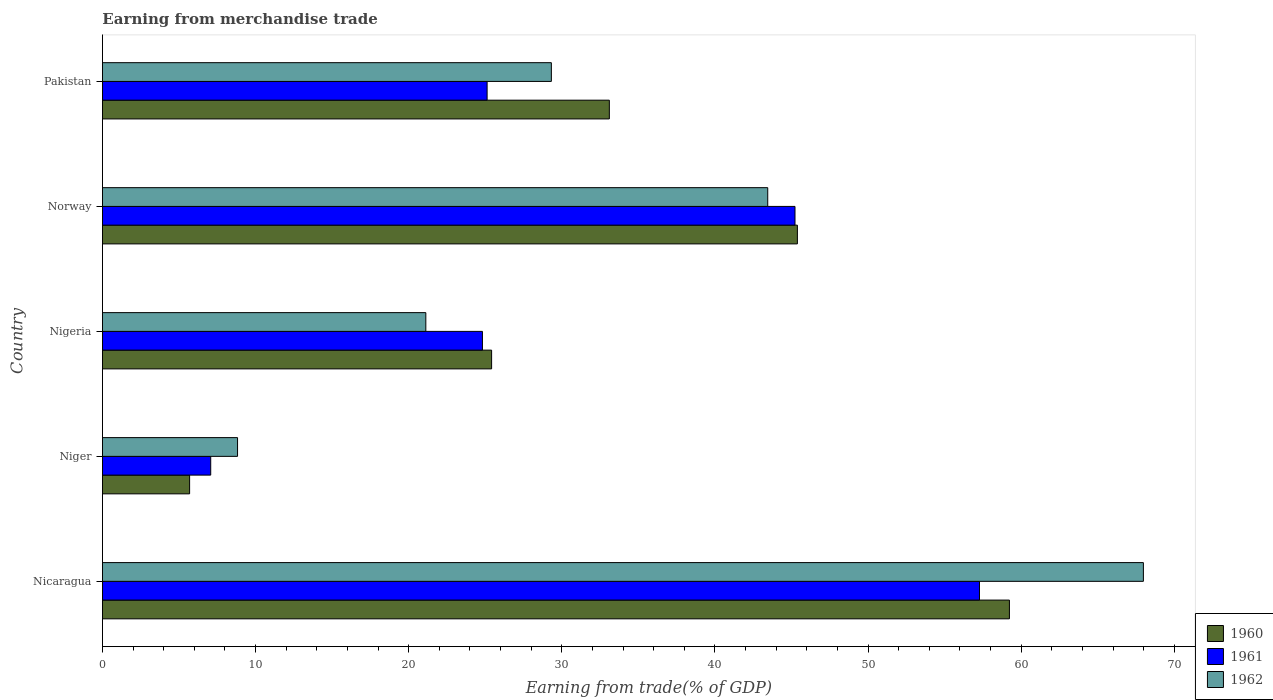How many different coloured bars are there?
Keep it short and to the point. 3. Are the number of bars per tick equal to the number of legend labels?
Your answer should be compact. Yes. How many bars are there on the 2nd tick from the top?
Offer a terse response. 3. How many bars are there on the 2nd tick from the bottom?
Offer a terse response. 3. What is the label of the 2nd group of bars from the top?
Provide a short and direct response. Norway. In how many cases, is the number of bars for a given country not equal to the number of legend labels?
Your response must be concise. 0. What is the earnings from trade in 1960 in Niger?
Offer a terse response. 5.69. Across all countries, what is the maximum earnings from trade in 1962?
Provide a succinct answer. 67.98. Across all countries, what is the minimum earnings from trade in 1961?
Offer a terse response. 7.07. In which country was the earnings from trade in 1960 maximum?
Provide a short and direct response. Nicaragua. In which country was the earnings from trade in 1961 minimum?
Your answer should be very brief. Niger. What is the total earnings from trade in 1962 in the graph?
Your response must be concise. 170.67. What is the difference between the earnings from trade in 1961 in Nigeria and that in Pakistan?
Make the answer very short. -0.31. What is the difference between the earnings from trade in 1962 in Norway and the earnings from trade in 1961 in Nigeria?
Your answer should be compact. 18.63. What is the average earnings from trade in 1960 per country?
Provide a short and direct response. 33.76. What is the difference between the earnings from trade in 1961 and earnings from trade in 1962 in Norway?
Your answer should be very brief. 1.78. What is the ratio of the earnings from trade in 1960 in Niger to that in Nigeria?
Give a very brief answer. 0.22. Is the earnings from trade in 1961 in Nigeria less than that in Pakistan?
Your answer should be compact. Yes. Is the difference between the earnings from trade in 1961 in Niger and Nigeria greater than the difference between the earnings from trade in 1962 in Niger and Nigeria?
Keep it short and to the point. No. What is the difference between the highest and the second highest earnings from trade in 1961?
Your answer should be compact. 12.05. What is the difference between the highest and the lowest earnings from trade in 1960?
Offer a terse response. 53.54. In how many countries, is the earnings from trade in 1960 greater than the average earnings from trade in 1960 taken over all countries?
Provide a short and direct response. 2. Is the sum of the earnings from trade in 1960 in Nicaragua and Niger greater than the maximum earnings from trade in 1962 across all countries?
Keep it short and to the point. No. What does the 2nd bar from the top in Niger represents?
Make the answer very short. 1961. Is it the case that in every country, the sum of the earnings from trade in 1961 and earnings from trade in 1960 is greater than the earnings from trade in 1962?
Your answer should be very brief. Yes. How many bars are there?
Offer a terse response. 15. Are all the bars in the graph horizontal?
Ensure brevity in your answer.  Yes. How many countries are there in the graph?
Your response must be concise. 5. Are the values on the major ticks of X-axis written in scientific E-notation?
Offer a very short reply. No. How many legend labels are there?
Ensure brevity in your answer.  3. What is the title of the graph?
Your response must be concise. Earning from merchandise trade. Does "1996" appear as one of the legend labels in the graph?
Your response must be concise. No. What is the label or title of the X-axis?
Offer a very short reply. Earning from trade(% of GDP). What is the Earning from trade(% of GDP) of 1960 in Nicaragua?
Make the answer very short. 59.23. What is the Earning from trade(% of GDP) of 1961 in Nicaragua?
Ensure brevity in your answer.  57.27. What is the Earning from trade(% of GDP) in 1962 in Nicaragua?
Your response must be concise. 67.98. What is the Earning from trade(% of GDP) in 1960 in Niger?
Provide a short and direct response. 5.69. What is the Earning from trade(% of GDP) of 1961 in Niger?
Offer a terse response. 7.07. What is the Earning from trade(% of GDP) of 1962 in Niger?
Ensure brevity in your answer.  8.82. What is the Earning from trade(% of GDP) of 1960 in Nigeria?
Offer a terse response. 25.41. What is the Earning from trade(% of GDP) of 1961 in Nigeria?
Offer a very short reply. 24.81. What is the Earning from trade(% of GDP) of 1962 in Nigeria?
Your answer should be very brief. 21.12. What is the Earning from trade(% of GDP) of 1960 in Norway?
Your answer should be very brief. 45.38. What is the Earning from trade(% of GDP) of 1961 in Norway?
Give a very brief answer. 45.23. What is the Earning from trade(% of GDP) in 1962 in Norway?
Provide a succinct answer. 43.44. What is the Earning from trade(% of GDP) in 1960 in Pakistan?
Your response must be concise. 33.1. What is the Earning from trade(% of GDP) in 1961 in Pakistan?
Ensure brevity in your answer.  25.12. What is the Earning from trade(% of GDP) of 1962 in Pakistan?
Keep it short and to the point. 29.31. Across all countries, what is the maximum Earning from trade(% of GDP) in 1960?
Offer a terse response. 59.23. Across all countries, what is the maximum Earning from trade(% of GDP) in 1961?
Offer a terse response. 57.27. Across all countries, what is the maximum Earning from trade(% of GDP) of 1962?
Make the answer very short. 67.98. Across all countries, what is the minimum Earning from trade(% of GDP) of 1960?
Your answer should be compact. 5.69. Across all countries, what is the minimum Earning from trade(% of GDP) in 1961?
Make the answer very short. 7.07. Across all countries, what is the minimum Earning from trade(% of GDP) of 1962?
Provide a short and direct response. 8.82. What is the total Earning from trade(% of GDP) in 1960 in the graph?
Offer a terse response. 168.82. What is the total Earning from trade(% of GDP) of 1961 in the graph?
Ensure brevity in your answer.  159.5. What is the total Earning from trade(% of GDP) in 1962 in the graph?
Your answer should be very brief. 170.67. What is the difference between the Earning from trade(% of GDP) of 1960 in Nicaragua and that in Niger?
Ensure brevity in your answer.  53.54. What is the difference between the Earning from trade(% of GDP) of 1961 in Nicaragua and that in Niger?
Provide a succinct answer. 50.2. What is the difference between the Earning from trade(% of GDP) in 1962 in Nicaragua and that in Niger?
Provide a succinct answer. 59.16. What is the difference between the Earning from trade(% of GDP) in 1960 in Nicaragua and that in Nigeria?
Offer a terse response. 33.81. What is the difference between the Earning from trade(% of GDP) in 1961 in Nicaragua and that in Nigeria?
Offer a terse response. 32.46. What is the difference between the Earning from trade(% of GDP) of 1962 in Nicaragua and that in Nigeria?
Offer a terse response. 46.86. What is the difference between the Earning from trade(% of GDP) of 1960 in Nicaragua and that in Norway?
Your answer should be very brief. 13.85. What is the difference between the Earning from trade(% of GDP) of 1961 in Nicaragua and that in Norway?
Ensure brevity in your answer.  12.05. What is the difference between the Earning from trade(% of GDP) in 1962 in Nicaragua and that in Norway?
Ensure brevity in your answer.  24.53. What is the difference between the Earning from trade(% of GDP) of 1960 in Nicaragua and that in Pakistan?
Offer a terse response. 26.13. What is the difference between the Earning from trade(% of GDP) in 1961 in Nicaragua and that in Pakistan?
Ensure brevity in your answer.  32.15. What is the difference between the Earning from trade(% of GDP) in 1962 in Nicaragua and that in Pakistan?
Your answer should be very brief. 38.66. What is the difference between the Earning from trade(% of GDP) in 1960 in Niger and that in Nigeria?
Your answer should be very brief. -19.72. What is the difference between the Earning from trade(% of GDP) of 1961 in Niger and that in Nigeria?
Offer a terse response. -17.75. What is the difference between the Earning from trade(% of GDP) in 1962 in Niger and that in Nigeria?
Make the answer very short. -12.3. What is the difference between the Earning from trade(% of GDP) of 1960 in Niger and that in Norway?
Ensure brevity in your answer.  -39.69. What is the difference between the Earning from trade(% of GDP) in 1961 in Niger and that in Norway?
Your response must be concise. -38.16. What is the difference between the Earning from trade(% of GDP) of 1962 in Niger and that in Norway?
Offer a terse response. -34.62. What is the difference between the Earning from trade(% of GDP) of 1960 in Niger and that in Pakistan?
Your answer should be very brief. -27.41. What is the difference between the Earning from trade(% of GDP) of 1961 in Niger and that in Pakistan?
Keep it short and to the point. -18.05. What is the difference between the Earning from trade(% of GDP) of 1962 in Niger and that in Pakistan?
Your answer should be very brief. -20.49. What is the difference between the Earning from trade(% of GDP) in 1960 in Nigeria and that in Norway?
Your answer should be very brief. -19.97. What is the difference between the Earning from trade(% of GDP) of 1961 in Nigeria and that in Norway?
Make the answer very short. -20.41. What is the difference between the Earning from trade(% of GDP) in 1962 in Nigeria and that in Norway?
Provide a short and direct response. -22.33. What is the difference between the Earning from trade(% of GDP) in 1960 in Nigeria and that in Pakistan?
Make the answer very short. -7.69. What is the difference between the Earning from trade(% of GDP) in 1961 in Nigeria and that in Pakistan?
Offer a very short reply. -0.31. What is the difference between the Earning from trade(% of GDP) in 1962 in Nigeria and that in Pakistan?
Your answer should be compact. -8.2. What is the difference between the Earning from trade(% of GDP) of 1960 in Norway and that in Pakistan?
Provide a short and direct response. 12.28. What is the difference between the Earning from trade(% of GDP) in 1961 in Norway and that in Pakistan?
Your answer should be compact. 20.11. What is the difference between the Earning from trade(% of GDP) in 1962 in Norway and that in Pakistan?
Give a very brief answer. 14.13. What is the difference between the Earning from trade(% of GDP) in 1960 in Nicaragua and the Earning from trade(% of GDP) in 1961 in Niger?
Make the answer very short. 52.16. What is the difference between the Earning from trade(% of GDP) in 1960 in Nicaragua and the Earning from trade(% of GDP) in 1962 in Niger?
Your response must be concise. 50.41. What is the difference between the Earning from trade(% of GDP) of 1961 in Nicaragua and the Earning from trade(% of GDP) of 1962 in Niger?
Offer a very short reply. 48.45. What is the difference between the Earning from trade(% of GDP) of 1960 in Nicaragua and the Earning from trade(% of GDP) of 1961 in Nigeria?
Your answer should be compact. 34.41. What is the difference between the Earning from trade(% of GDP) in 1960 in Nicaragua and the Earning from trade(% of GDP) in 1962 in Nigeria?
Your response must be concise. 38.11. What is the difference between the Earning from trade(% of GDP) of 1961 in Nicaragua and the Earning from trade(% of GDP) of 1962 in Nigeria?
Keep it short and to the point. 36.16. What is the difference between the Earning from trade(% of GDP) of 1960 in Nicaragua and the Earning from trade(% of GDP) of 1961 in Norway?
Ensure brevity in your answer.  14. What is the difference between the Earning from trade(% of GDP) in 1960 in Nicaragua and the Earning from trade(% of GDP) in 1962 in Norway?
Provide a short and direct response. 15.78. What is the difference between the Earning from trade(% of GDP) in 1961 in Nicaragua and the Earning from trade(% of GDP) in 1962 in Norway?
Your response must be concise. 13.83. What is the difference between the Earning from trade(% of GDP) of 1960 in Nicaragua and the Earning from trade(% of GDP) of 1961 in Pakistan?
Ensure brevity in your answer.  34.11. What is the difference between the Earning from trade(% of GDP) of 1960 in Nicaragua and the Earning from trade(% of GDP) of 1962 in Pakistan?
Your response must be concise. 29.91. What is the difference between the Earning from trade(% of GDP) of 1961 in Nicaragua and the Earning from trade(% of GDP) of 1962 in Pakistan?
Give a very brief answer. 27.96. What is the difference between the Earning from trade(% of GDP) of 1960 in Niger and the Earning from trade(% of GDP) of 1961 in Nigeria?
Give a very brief answer. -19.12. What is the difference between the Earning from trade(% of GDP) in 1960 in Niger and the Earning from trade(% of GDP) in 1962 in Nigeria?
Provide a succinct answer. -15.43. What is the difference between the Earning from trade(% of GDP) of 1961 in Niger and the Earning from trade(% of GDP) of 1962 in Nigeria?
Offer a terse response. -14.05. What is the difference between the Earning from trade(% of GDP) of 1960 in Niger and the Earning from trade(% of GDP) of 1961 in Norway?
Your answer should be very brief. -39.53. What is the difference between the Earning from trade(% of GDP) of 1960 in Niger and the Earning from trade(% of GDP) of 1962 in Norway?
Provide a short and direct response. -37.75. What is the difference between the Earning from trade(% of GDP) in 1961 in Niger and the Earning from trade(% of GDP) in 1962 in Norway?
Your response must be concise. -36.38. What is the difference between the Earning from trade(% of GDP) in 1960 in Niger and the Earning from trade(% of GDP) in 1961 in Pakistan?
Offer a very short reply. -19.43. What is the difference between the Earning from trade(% of GDP) of 1960 in Niger and the Earning from trade(% of GDP) of 1962 in Pakistan?
Offer a terse response. -23.62. What is the difference between the Earning from trade(% of GDP) of 1961 in Niger and the Earning from trade(% of GDP) of 1962 in Pakistan?
Offer a very short reply. -22.25. What is the difference between the Earning from trade(% of GDP) in 1960 in Nigeria and the Earning from trade(% of GDP) in 1961 in Norway?
Keep it short and to the point. -19.81. What is the difference between the Earning from trade(% of GDP) in 1960 in Nigeria and the Earning from trade(% of GDP) in 1962 in Norway?
Provide a succinct answer. -18.03. What is the difference between the Earning from trade(% of GDP) in 1961 in Nigeria and the Earning from trade(% of GDP) in 1962 in Norway?
Keep it short and to the point. -18.63. What is the difference between the Earning from trade(% of GDP) of 1960 in Nigeria and the Earning from trade(% of GDP) of 1961 in Pakistan?
Your response must be concise. 0.29. What is the difference between the Earning from trade(% of GDP) in 1960 in Nigeria and the Earning from trade(% of GDP) in 1962 in Pakistan?
Provide a short and direct response. -3.9. What is the difference between the Earning from trade(% of GDP) in 1961 in Nigeria and the Earning from trade(% of GDP) in 1962 in Pakistan?
Provide a short and direct response. -4.5. What is the difference between the Earning from trade(% of GDP) in 1960 in Norway and the Earning from trade(% of GDP) in 1961 in Pakistan?
Your response must be concise. 20.26. What is the difference between the Earning from trade(% of GDP) in 1960 in Norway and the Earning from trade(% of GDP) in 1962 in Pakistan?
Your answer should be very brief. 16.07. What is the difference between the Earning from trade(% of GDP) in 1961 in Norway and the Earning from trade(% of GDP) in 1962 in Pakistan?
Make the answer very short. 15.91. What is the average Earning from trade(% of GDP) in 1960 per country?
Provide a succinct answer. 33.76. What is the average Earning from trade(% of GDP) in 1961 per country?
Keep it short and to the point. 31.9. What is the average Earning from trade(% of GDP) in 1962 per country?
Provide a succinct answer. 34.13. What is the difference between the Earning from trade(% of GDP) of 1960 and Earning from trade(% of GDP) of 1961 in Nicaragua?
Provide a succinct answer. 1.95. What is the difference between the Earning from trade(% of GDP) in 1960 and Earning from trade(% of GDP) in 1962 in Nicaragua?
Give a very brief answer. -8.75. What is the difference between the Earning from trade(% of GDP) of 1961 and Earning from trade(% of GDP) of 1962 in Nicaragua?
Offer a terse response. -10.7. What is the difference between the Earning from trade(% of GDP) of 1960 and Earning from trade(% of GDP) of 1961 in Niger?
Your answer should be very brief. -1.38. What is the difference between the Earning from trade(% of GDP) of 1960 and Earning from trade(% of GDP) of 1962 in Niger?
Give a very brief answer. -3.13. What is the difference between the Earning from trade(% of GDP) in 1961 and Earning from trade(% of GDP) in 1962 in Niger?
Give a very brief answer. -1.75. What is the difference between the Earning from trade(% of GDP) of 1960 and Earning from trade(% of GDP) of 1961 in Nigeria?
Provide a short and direct response. 0.6. What is the difference between the Earning from trade(% of GDP) of 1960 and Earning from trade(% of GDP) of 1962 in Nigeria?
Ensure brevity in your answer.  4.3. What is the difference between the Earning from trade(% of GDP) of 1961 and Earning from trade(% of GDP) of 1962 in Nigeria?
Your response must be concise. 3.7. What is the difference between the Earning from trade(% of GDP) of 1960 and Earning from trade(% of GDP) of 1961 in Norway?
Provide a succinct answer. 0.16. What is the difference between the Earning from trade(% of GDP) in 1960 and Earning from trade(% of GDP) in 1962 in Norway?
Offer a very short reply. 1.94. What is the difference between the Earning from trade(% of GDP) in 1961 and Earning from trade(% of GDP) in 1962 in Norway?
Your answer should be compact. 1.78. What is the difference between the Earning from trade(% of GDP) of 1960 and Earning from trade(% of GDP) of 1961 in Pakistan?
Ensure brevity in your answer.  7.98. What is the difference between the Earning from trade(% of GDP) of 1960 and Earning from trade(% of GDP) of 1962 in Pakistan?
Offer a very short reply. 3.79. What is the difference between the Earning from trade(% of GDP) in 1961 and Earning from trade(% of GDP) in 1962 in Pakistan?
Offer a terse response. -4.2. What is the ratio of the Earning from trade(% of GDP) of 1960 in Nicaragua to that in Niger?
Provide a short and direct response. 10.41. What is the ratio of the Earning from trade(% of GDP) of 1961 in Nicaragua to that in Niger?
Give a very brief answer. 8.1. What is the ratio of the Earning from trade(% of GDP) of 1962 in Nicaragua to that in Niger?
Make the answer very short. 7.71. What is the ratio of the Earning from trade(% of GDP) of 1960 in Nicaragua to that in Nigeria?
Provide a short and direct response. 2.33. What is the ratio of the Earning from trade(% of GDP) in 1961 in Nicaragua to that in Nigeria?
Give a very brief answer. 2.31. What is the ratio of the Earning from trade(% of GDP) in 1962 in Nicaragua to that in Nigeria?
Provide a short and direct response. 3.22. What is the ratio of the Earning from trade(% of GDP) in 1960 in Nicaragua to that in Norway?
Offer a very short reply. 1.31. What is the ratio of the Earning from trade(% of GDP) of 1961 in Nicaragua to that in Norway?
Provide a short and direct response. 1.27. What is the ratio of the Earning from trade(% of GDP) of 1962 in Nicaragua to that in Norway?
Your response must be concise. 1.56. What is the ratio of the Earning from trade(% of GDP) of 1960 in Nicaragua to that in Pakistan?
Your answer should be very brief. 1.79. What is the ratio of the Earning from trade(% of GDP) in 1961 in Nicaragua to that in Pakistan?
Your answer should be very brief. 2.28. What is the ratio of the Earning from trade(% of GDP) in 1962 in Nicaragua to that in Pakistan?
Offer a terse response. 2.32. What is the ratio of the Earning from trade(% of GDP) in 1960 in Niger to that in Nigeria?
Provide a succinct answer. 0.22. What is the ratio of the Earning from trade(% of GDP) of 1961 in Niger to that in Nigeria?
Provide a short and direct response. 0.28. What is the ratio of the Earning from trade(% of GDP) of 1962 in Niger to that in Nigeria?
Provide a short and direct response. 0.42. What is the ratio of the Earning from trade(% of GDP) in 1960 in Niger to that in Norway?
Ensure brevity in your answer.  0.13. What is the ratio of the Earning from trade(% of GDP) in 1961 in Niger to that in Norway?
Provide a succinct answer. 0.16. What is the ratio of the Earning from trade(% of GDP) of 1962 in Niger to that in Norway?
Provide a succinct answer. 0.2. What is the ratio of the Earning from trade(% of GDP) in 1960 in Niger to that in Pakistan?
Keep it short and to the point. 0.17. What is the ratio of the Earning from trade(% of GDP) of 1961 in Niger to that in Pakistan?
Offer a terse response. 0.28. What is the ratio of the Earning from trade(% of GDP) in 1962 in Niger to that in Pakistan?
Ensure brevity in your answer.  0.3. What is the ratio of the Earning from trade(% of GDP) in 1960 in Nigeria to that in Norway?
Your response must be concise. 0.56. What is the ratio of the Earning from trade(% of GDP) in 1961 in Nigeria to that in Norway?
Ensure brevity in your answer.  0.55. What is the ratio of the Earning from trade(% of GDP) in 1962 in Nigeria to that in Norway?
Make the answer very short. 0.49. What is the ratio of the Earning from trade(% of GDP) of 1960 in Nigeria to that in Pakistan?
Offer a very short reply. 0.77. What is the ratio of the Earning from trade(% of GDP) in 1961 in Nigeria to that in Pakistan?
Your answer should be compact. 0.99. What is the ratio of the Earning from trade(% of GDP) in 1962 in Nigeria to that in Pakistan?
Make the answer very short. 0.72. What is the ratio of the Earning from trade(% of GDP) in 1960 in Norway to that in Pakistan?
Provide a short and direct response. 1.37. What is the ratio of the Earning from trade(% of GDP) in 1961 in Norway to that in Pakistan?
Your answer should be very brief. 1.8. What is the ratio of the Earning from trade(% of GDP) in 1962 in Norway to that in Pakistan?
Provide a short and direct response. 1.48. What is the difference between the highest and the second highest Earning from trade(% of GDP) in 1960?
Provide a short and direct response. 13.85. What is the difference between the highest and the second highest Earning from trade(% of GDP) in 1961?
Offer a very short reply. 12.05. What is the difference between the highest and the second highest Earning from trade(% of GDP) in 1962?
Offer a terse response. 24.53. What is the difference between the highest and the lowest Earning from trade(% of GDP) in 1960?
Your answer should be compact. 53.54. What is the difference between the highest and the lowest Earning from trade(% of GDP) in 1961?
Your response must be concise. 50.2. What is the difference between the highest and the lowest Earning from trade(% of GDP) in 1962?
Your response must be concise. 59.16. 